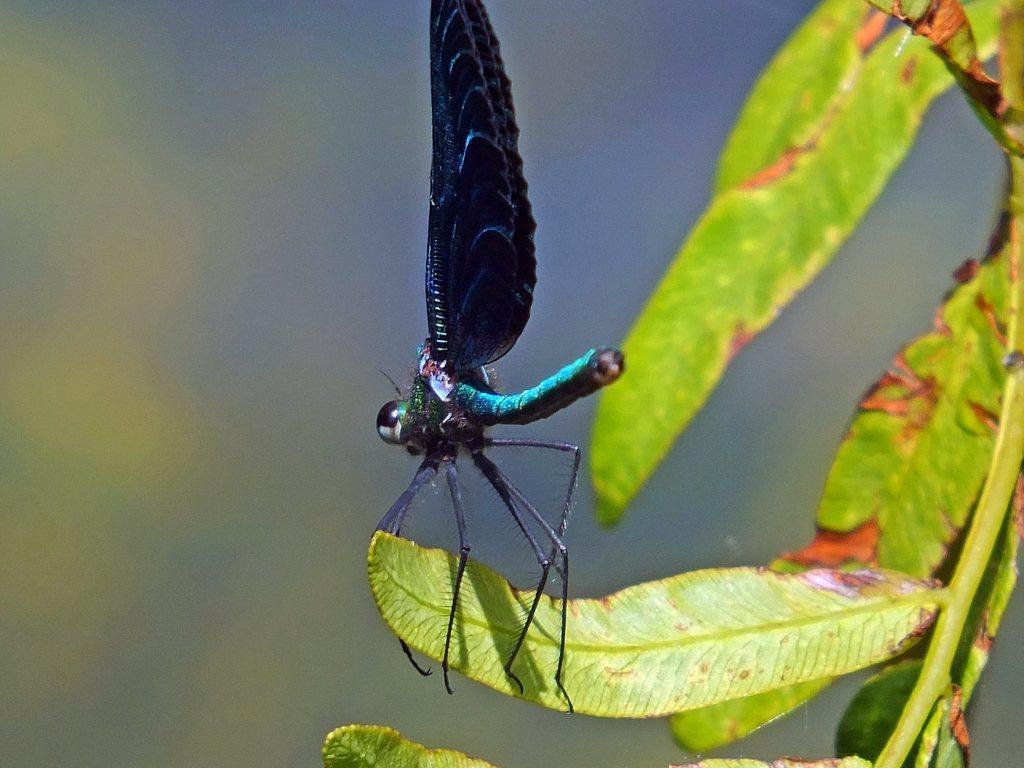In one or two sentences, can you explain what this image depicts? In this image, we can see some green leaves, there is an insect on the leaf, there is a blurred background. 